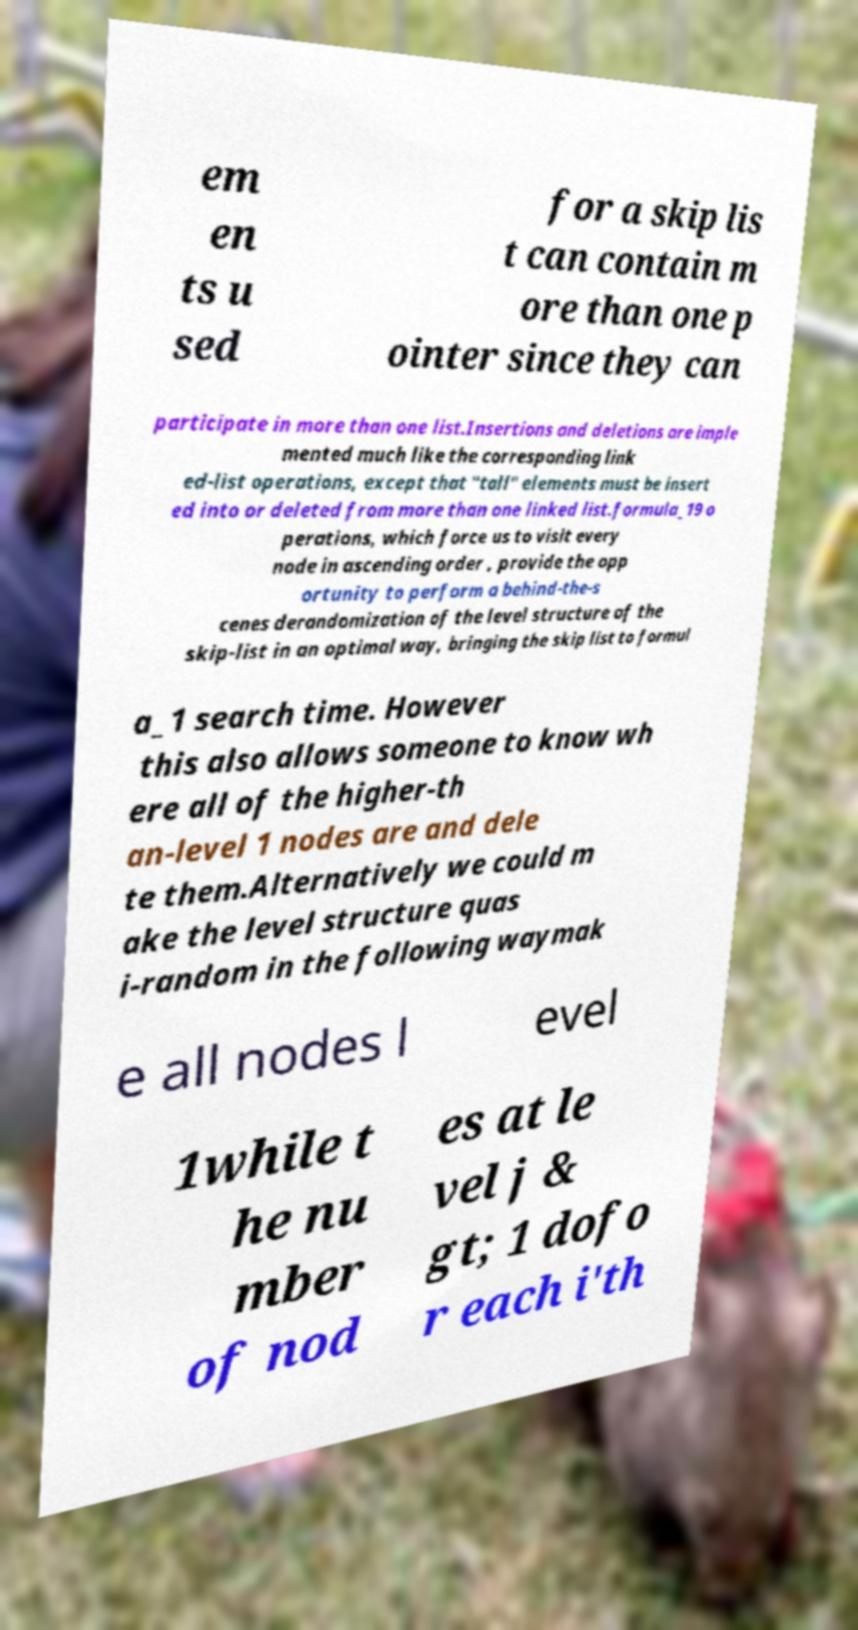Can you accurately transcribe the text from the provided image for me? em en ts u sed for a skip lis t can contain m ore than one p ointer since they can participate in more than one list.Insertions and deletions are imple mented much like the corresponding link ed-list operations, except that "tall" elements must be insert ed into or deleted from more than one linked list.formula_19 o perations, which force us to visit every node in ascending order , provide the opp ortunity to perform a behind-the-s cenes derandomization of the level structure of the skip-list in an optimal way, bringing the skip list to formul a_1 search time. However this also allows someone to know wh ere all of the higher-th an-level 1 nodes are and dele te them.Alternatively we could m ake the level structure quas i-random in the following waymak e all nodes l evel 1while t he nu mber of nod es at le vel j & gt; 1 dofo r each i'th 